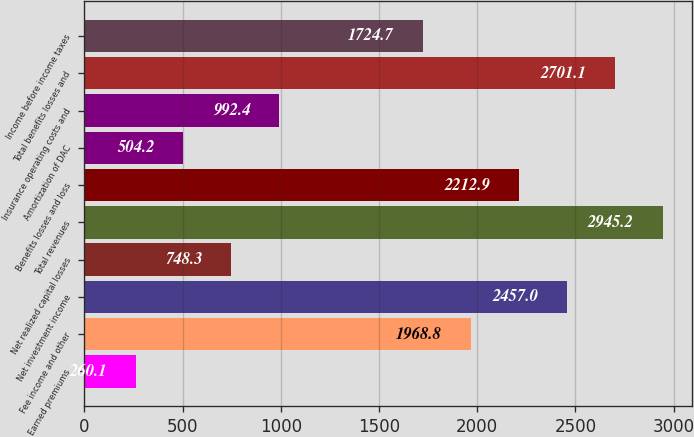<chart> <loc_0><loc_0><loc_500><loc_500><bar_chart><fcel>Earned premiums<fcel>Fee income and other<fcel>Net investment income<fcel>Net realized capital losses<fcel>Total revenues<fcel>Benefits losses and loss<fcel>Amortization of DAC<fcel>Insurance operating costs and<fcel>Total benefits losses and<fcel>Income before income taxes<nl><fcel>260.1<fcel>1968.8<fcel>2457<fcel>748.3<fcel>2945.2<fcel>2212.9<fcel>504.2<fcel>992.4<fcel>2701.1<fcel>1724.7<nl></chart> 